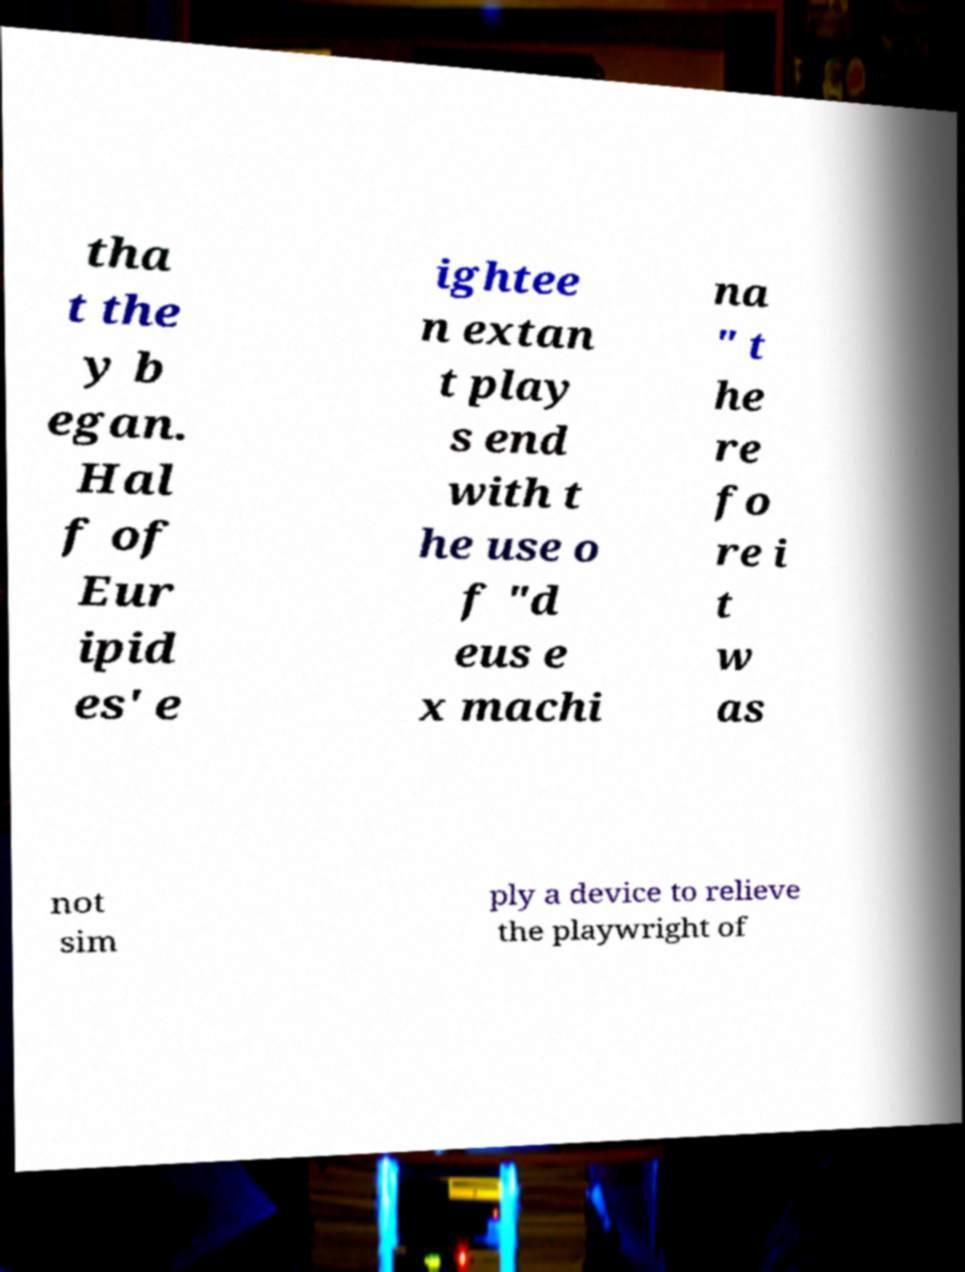For documentation purposes, I need the text within this image transcribed. Could you provide that? tha t the y b egan. Hal f of Eur ipid es' e ightee n extan t play s end with t he use o f "d eus e x machi na " t he re fo re i t w as not sim ply a device to relieve the playwright of 